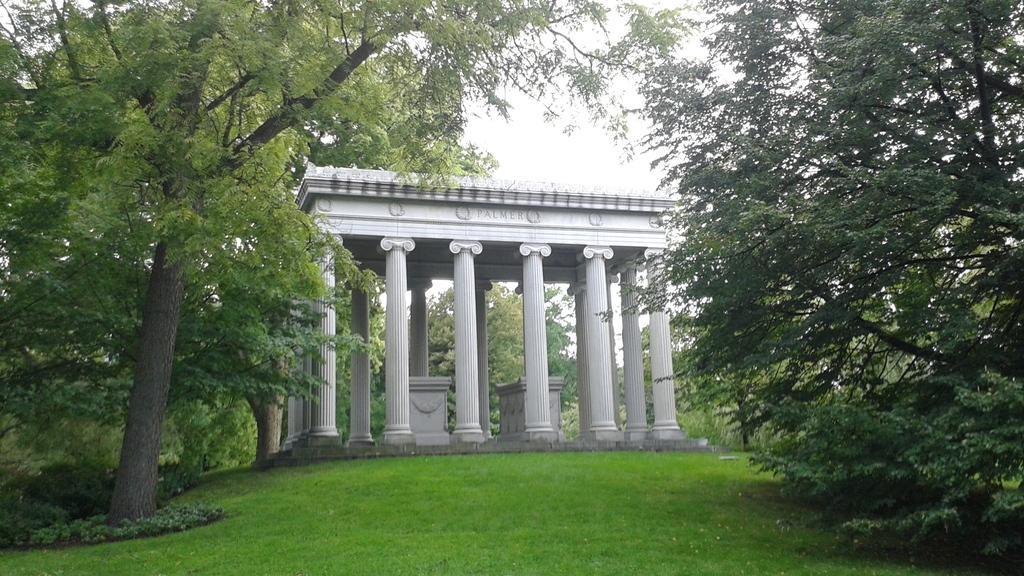How would you summarize this image in a sentence or two? In the image i can see a white building,trees,grass and finally i can see the sky. 